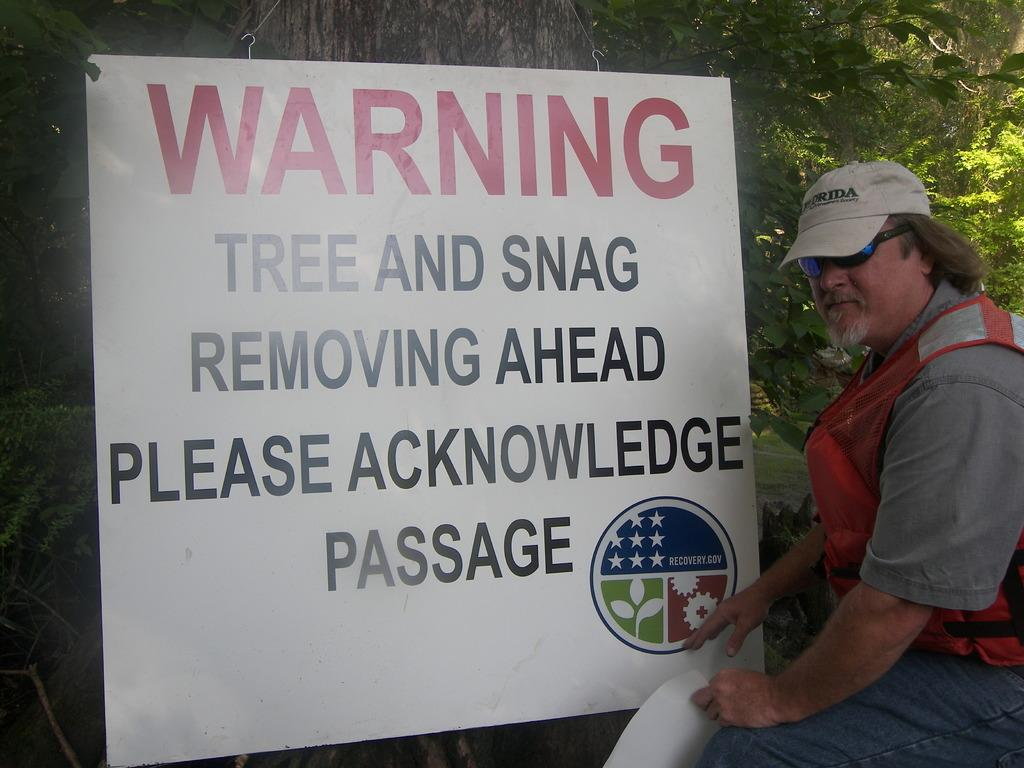Who is present in the image? There is a person in the image. What protective gear is the person wearing? The person is wearing goggles and a cap. What is the person holding in the image? The person is holding a paper. Can you describe any additional features in the image? There is a banner with text hanging in a tree. What type of shock can be seen coming from the person's tail in the image? There is no tail present on the person in the image, so there is no shock coming from it. 